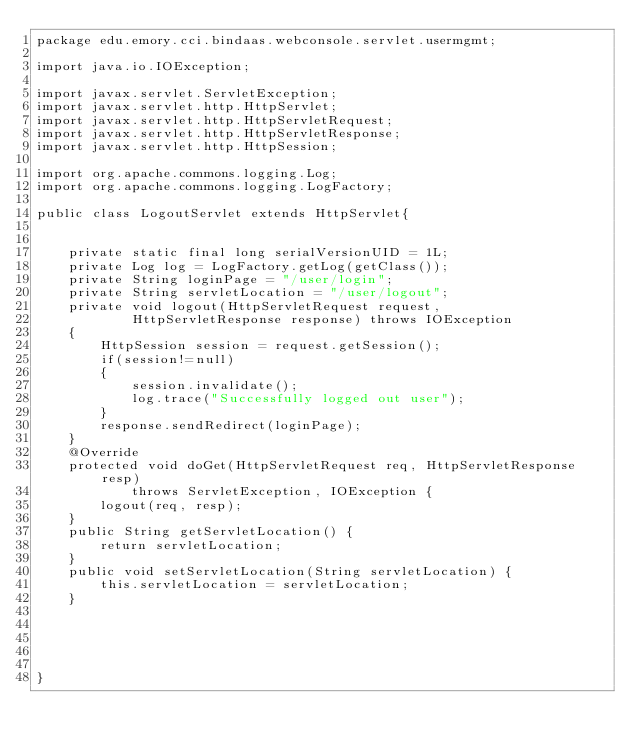Convert code to text. <code><loc_0><loc_0><loc_500><loc_500><_Java_>package edu.emory.cci.bindaas.webconsole.servlet.usermgmt;

import java.io.IOException;

import javax.servlet.ServletException;
import javax.servlet.http.HttpServlet;
import javax.servlet.http.HttpServletRequest;
import javax.servlet.http.HttpServletResponse;
import javax.servlet.http.HttpSession;

import org.apache.commons.logging.Log;
import org.apache.commons.logging.LogFactory;

public class LogoutServlet extends HttpServlet{
	
	
	private static final long serialVersionUID = 1L;
	private Log log = LogFactory.getLog(getClass());
	private String loginPage = "/user/login";
	private String servletLocation = "/user/logout";
	private void logout(HttpServletRequest request,
			HttpServletResponse response) throws IOException
	{
		HttpSession session = request.getSession();
		if(session!=null)
		{
			session.invalidate();
			log.trace("Successfully logged out user");
		}
		response.sendRedirect(loginPage);
	}
	@Override
	protected void doGet(HttpServletRequest req, HttpServletResponse resp)
			throws ServletException, IOException {
		logout(req, resp);
	}
	public String getServletLocation() {
		return servletLocation;
	}
	public void setServletLocation(String servletLocation) {
		this.servletLocation = servletLocation;
	}
	
	



}
</code> 